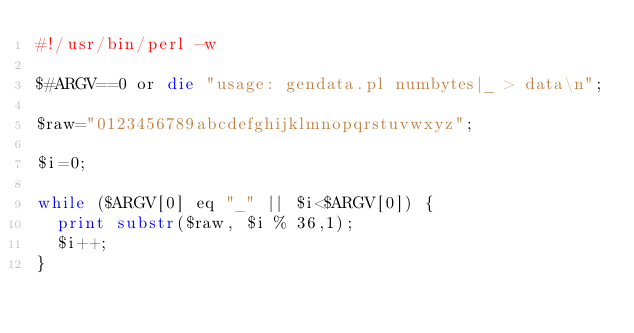<code> <loc_0><loc_0><loc_500><loc_500><_Perl_>#!/usr/bin/perl -w

$#ARGV==0 or die "usage: gendata.pl numbytes|_ > data\n";

$raw="0123456789abcdefghijklmnopqrstuvwxyz";

$i=0;

while ($ARGV[0] eq "_" || $i<$ARGV[0]) {
  print substr($raw, $i % 36,1);
  $i++;
}

</code> 